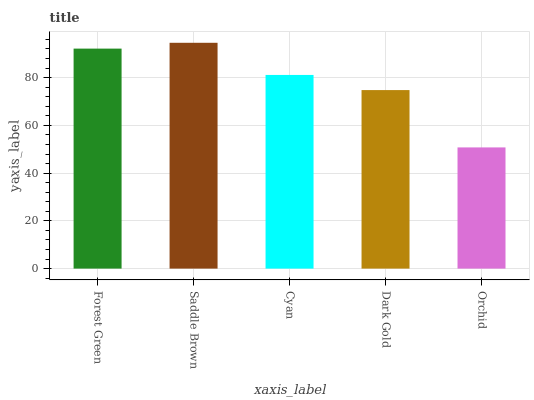Is Cyan the minimum?
Answer yes or no. No. Is Cyan the maximum?
Answer yes or no. No. Is Saddle Brown greater than Cyan?
Answer yes or no. Yes. Is Cyan less than Saddle Brown?
Answer yes or no. Yes. Is Cyan greater than Saddle Brown?
Answer yes or no. No. Is Saddle Brown less than Cyan?
Answer yes or no. No. Is Cyan the high median?
Answer yes or no. Yes. Is Cyan the low median?
Answer yes or no. Yes. Is Saddle Brown the high median?
Answer yes or no. No. Is Dark Gold the low median?
Answer yes or no. No. 